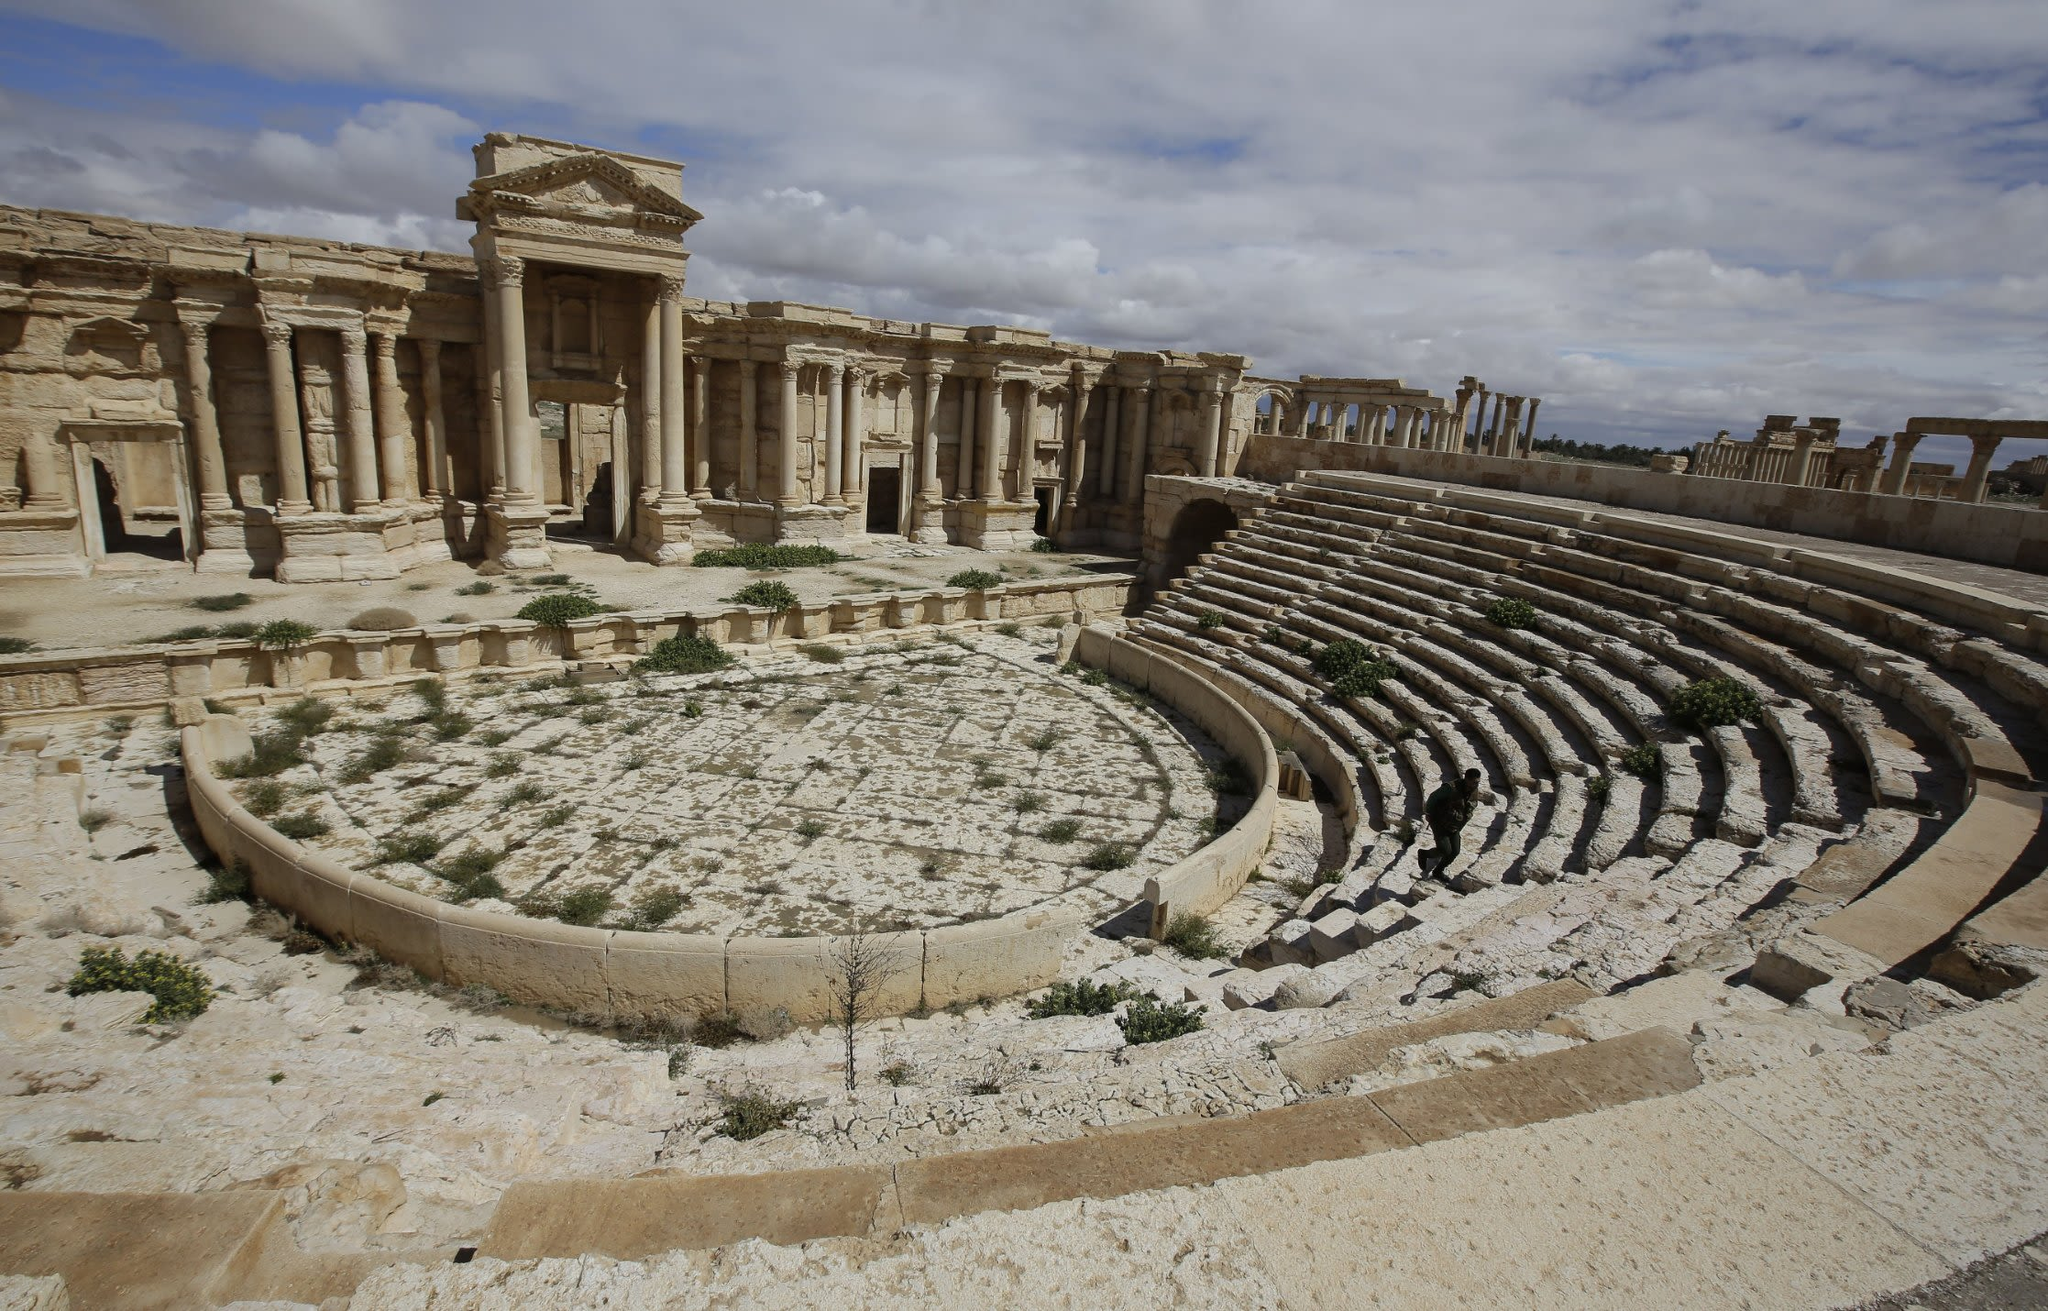Could you describe a possible secret hidden within these ruins? The ruins of Palmyra might conceal a plethora of secrets, one of which could be an ancient script carved into the stone, hidden beneath layers of debris and time. This script might reveal lost knowledge or forgotten tales of the kingdom. Imagine if one of the columns bore an inscription detailing a hidden chamber beneath the theater, filled with artifacts – ancient scrolls, exotic relics, or treasures from far-off lands traded through the Silk Road. Such a discovery could offer unprecedented insights into the cultural and historical exchanges that Palmyra was a part of. This secret chamber could serve as a time capsule, preserving the essence of an era long past, waiting to be uncovered by modern explorers. 